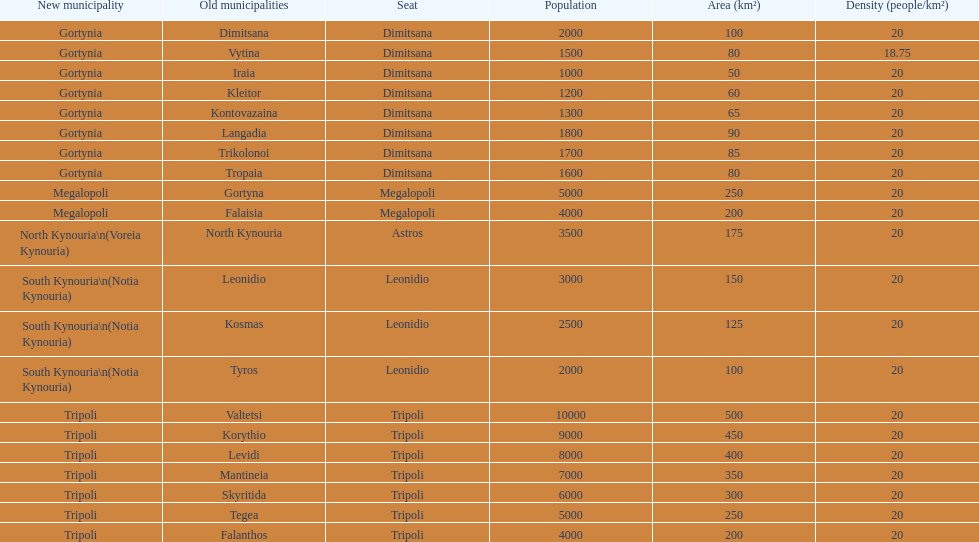After the 2011 reorganization, does tripoli continue to be a municipality in arcadia? Yes. 